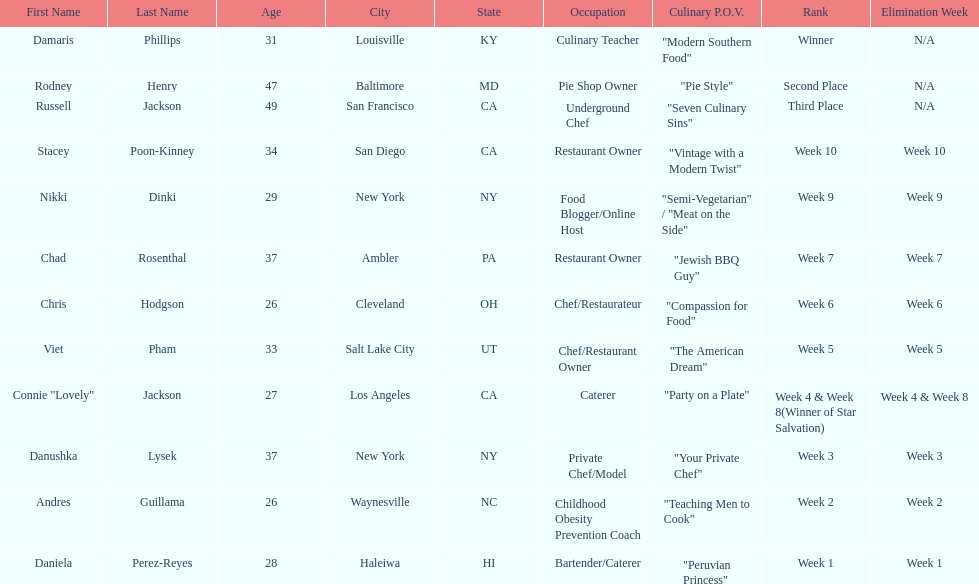Who was the top chef? Damaris Phillips. 